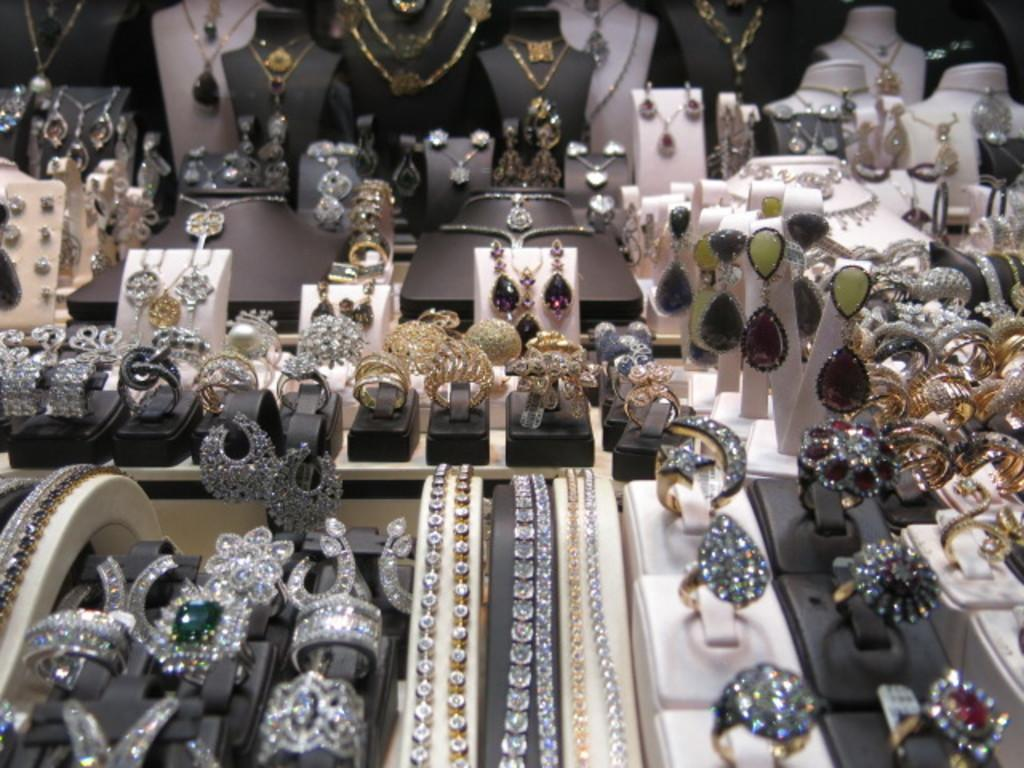What type of items can be seen in the image? There are jewelry items in the image. How are the jewelry items arranged in the image? The jewelry items are kept one beside another. What type of furniture can be seen in the image? There is no furniture present in the image; it only features jewelry items. How many bikes are visible in the image? There are no bikes present in the image. 